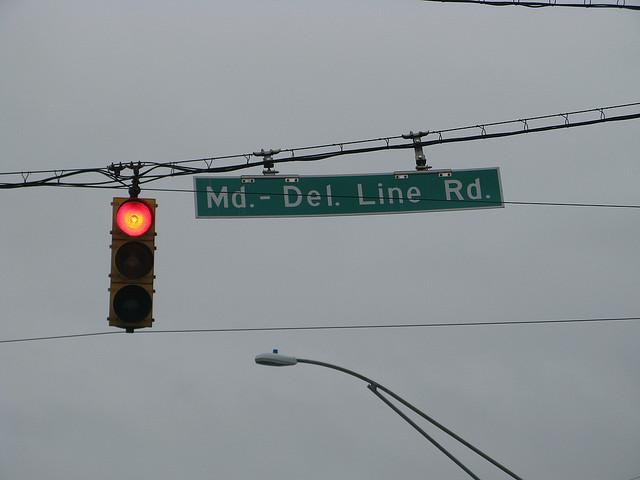What color is the stoplight?
Give a very brief answer. Red. What does the light indicate?
Write a very short answer. Stop. What road is this?
Give a very brief answer. Md - del line rd. What kind of day is it?
Short answer required. Cloudy. Is the light green?
Quick response, please. No. 